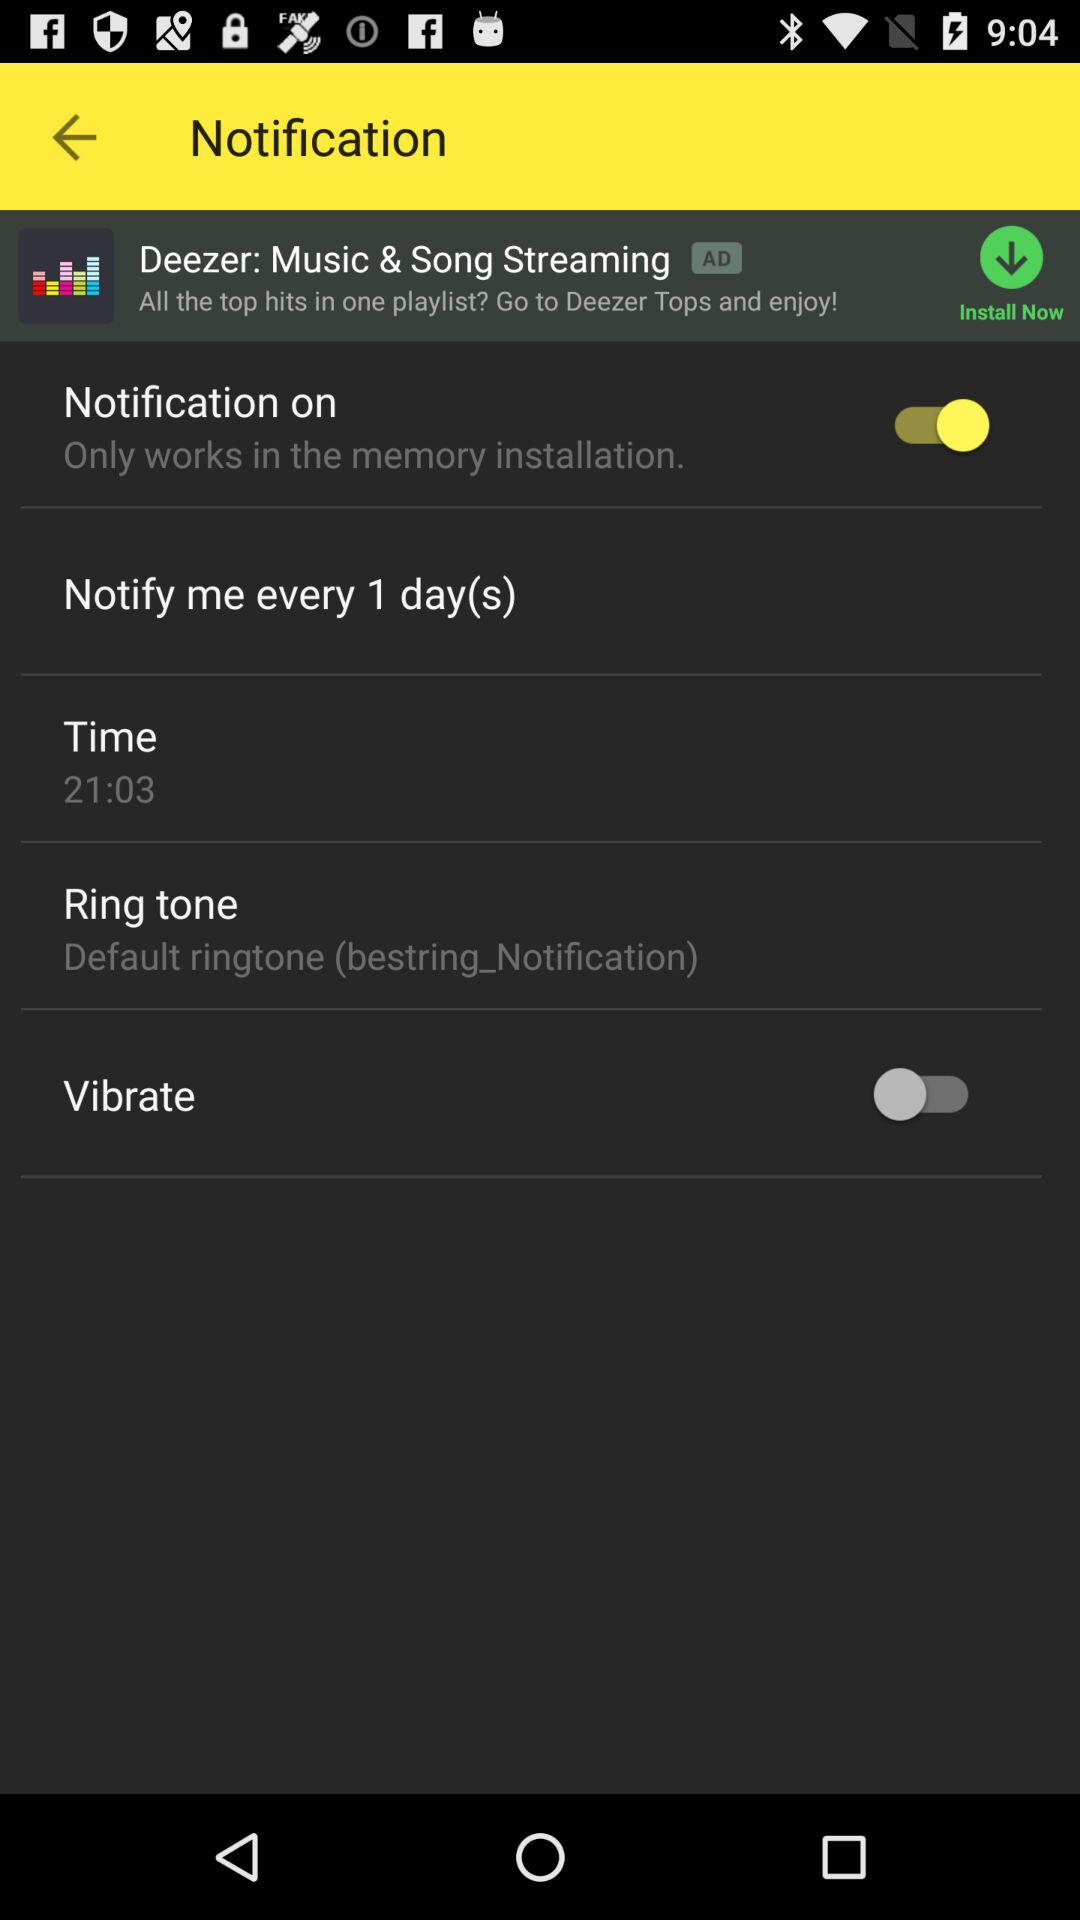What is the notification time? The notification time is 21:03. 